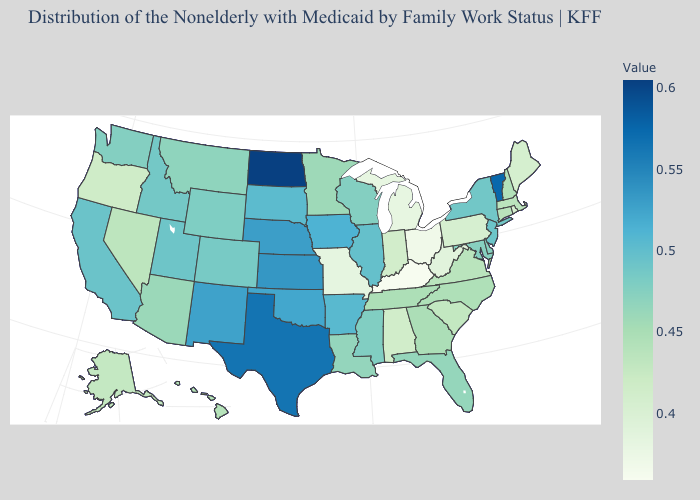Does North Dakota have the highest value in the USA?
Be succinct. Yes. Which states hav the highest value in the South?
Write a very short answer. Texas. Among the states that border New York , which have the lowest value?
Be succinct. Pennsylvania. Among the states that border Nebraska , does Missouri have the lowest value?
Be succinct. Yes. Among the states that border New Mexico , does Oklahoma have the lowest value?
Short answer required. No. Does Kentucky have the lowest value in the USA?
Give a very brief answer. Yes. 